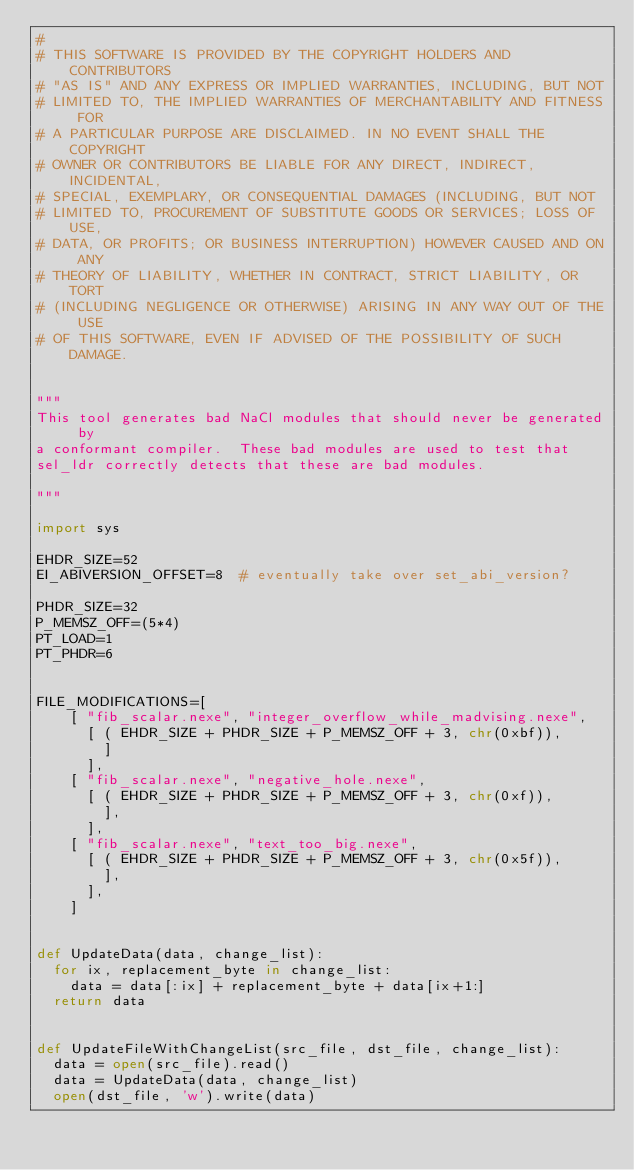<code> <loc_0><loc_0><loc_500><loc_500><_Python_>#
# THIS SOFTWARE IS PROVIDED BY THE COPYRIGHT HOLDERS AND CONTRIBUTORS
# "AS IS" AND ANY EXPRESS OR IMPLIED WARRANTIES, INCLUDING, BUT NOT
# LIMITED TO, THE IMPLIED WARRANTIES OF MERCHANTABILITY AND FITNESS FOR
# A PARTICULAR PURPOSE ARE DISCLAIMED. IN NO EVENT SHALL THE COPYRIGHT
# OWNER OR CONTRIBUTORS BE LIABLE FOR ANY DIRECT, INDIRECT, INCIDENTAL,
# SPECIAL, EXEMPLARY, OR CONSEQUENTIAL DAMAGES (INCLUDING, BUT NOT
# LIMITED TO, PROCUREMENT OF SUBSTITUTE GOODS OR SERVICES; LOSS OF USE,
# DATA, OR PROFITS; OR BUSINESS INTERRUPTION) HOWEVER CAUSED AND ON ANY
# THEORY OF LIABILITY, WHETHER IN CONTRACT, STRICT LIABILITY, OR TORT
# (INCLUDING NEGLIGENCE OR OTHERWISE) ARISING IN ANY WAY OUT OF THE USE
# OF THIS SOFTWARE, EVEN IF ADVISED OF THE POSSIBILITY OF SUCH DAMAGE.


"""
This tool generates bad NaCl modules that should never be generated by
a conformant compiler.  These bad modules are used to test that
sel_ldr correctly detects that these are bad modules.

"""

import sys

EHDR_SIZE=52
EI_ABIVERSION_OFFSET=8  # eventually take over set_abi_version?

PHDR_SIZE=32
P_MEMSZ_OFF=(5*4)
PT_LOAD=1
PT_PHDR=6


FILE_MODIFICATIONS=[
    [ "fib_scalar.nexe", "integer_overflow_while_madvising.nexe",
      [ ( EHDR_SIZE + PHDR_SIZE + P_MEMSZ_OFF + 3, chr(0xbf)),
        ]
      ],
    [ "fib_scalar.nexe", "negative_hole.nexe",
      [ ( EHDR_SIZE + PHDR_SIZE + P_MEMSZ_OFF + 3, chr(0xf)),
        ],
      ],
    [ "fib_scalar.nexe", "text_too_big.nexe",
      [ ( EHDR_SIZE + PHDR_SIZE + P_MEMSZ_OFF + 3, chr(0x5f)),
        ],
      ],
    ]


def UpdateData(data, change_list):
  for ix, replacement_byte in change_list:
    data = data[:ix] + replacement_byte + data[ix+1:]
  return data


def UpdateFileWithChangeList(src_file, dst_file, change_list):
  data = open(src_file).read()
  data = UpdateData(data, change_list)
  open(dst_file, 'w').write(data)
</code> 